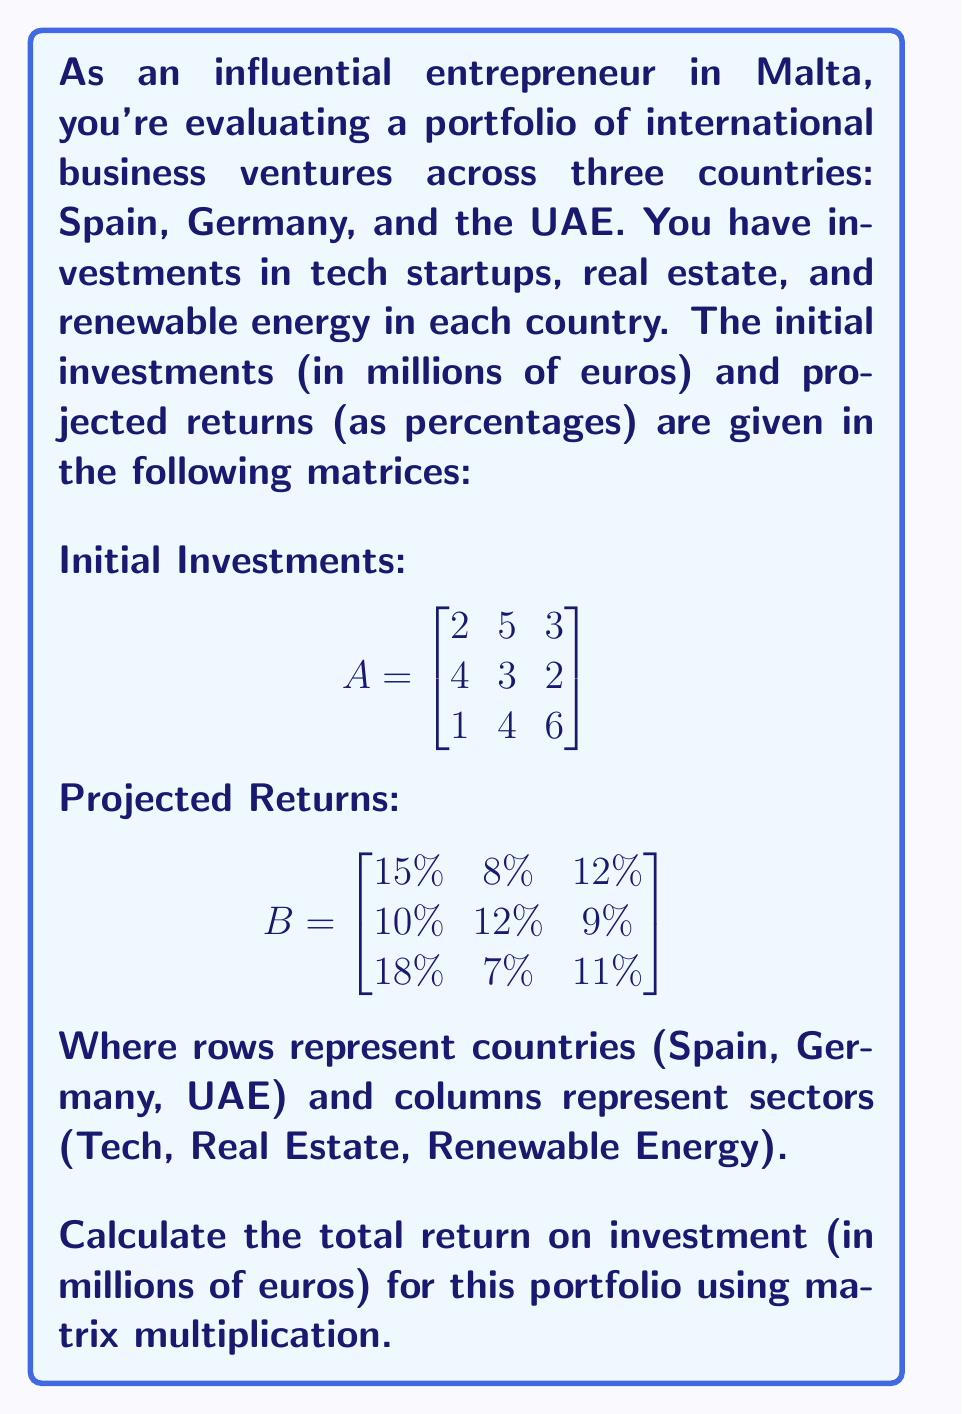Can you solve this math problem? To solve this problem, we need to follow these steps:

1) First, we need to convert the percentage returns in matrix B to decimal form:

$$B = \begin{bmatrix}
0.15 & 0.08 & 0.12 \\
0.10 & 0.12 & 0.09 \\
0.18 & 0.07 & 0.11
\end{bmatrix}$$

2) Next, we multiply matrices A and B. The resulting matrix C will give us the returns for each investment in millions of euros.

$$C = A \cdot B$$

3) To perform this multiplication:

$$c_{ij} = \sum_{k=1}^{3} a_{ik} \cdot b_{kj}$$

Let's calculate each element:

$c_{11} = 2(0.15) + 5(0.10) + 3(0.18) = 0.30 + 0.50 + 0.54 = 1.34$
$c_{12} = 2(0.08) + 5(0.12) + 3(0.07) = 0.16 + 0.60 + 0.21 = 0.97$
$c_{13} = 2(0.12) + 5(0.09) + 3(0.11) = 0.24 + 0.45 + 0.33 = 1.02$

$c_{21} = 4(0.15) + 3(0.10) + 2(0.18) = 0.60 + 0.30 + 0.36 = 1.26$
$c_{22} = 4(0.08) + 3(0.12) + 2(0.07) = 0.32 + 0.36 + 0.14 = 0.82$
$c_{23} = 4(0.12) + 3(0.09) + 2(0.11) = 0.48 + 0.27 + 0.22 = 0.97$

$c_{31} = 1(0.15) + 4(0.10) + 6(0.18) = 0.15 + 0.40 + 1.08 = 1.63$
$c_{32} = 1(0.08) + 4(0.12) + 6(0.07) = 0.08 + 0.48 + 0.42 = 0.98$
$c_{33} = 1(0.12) + 4(0.09) + 6(0.11) = 0.12 + 0.36 + 0.66 = 1.14$

4) Therefore, the resulting matrix C is:

$$C = \begin{bmatrix}
1.34 & 0.97 & 1.02 \\
1.26 & 0.82 & 0.97 \\
1.63 & 0.98 & 1.14
\end{bmatrix}$$

5) To get the total return on investment, we sum all elements of matrix C:

Total ROI = 1.34 + 0.97 + 1.02 + 1.26 + 0.82 + 0.97 + 1.63 + 0.98 + 1.14 = 10.13

Therefore, the total return on investment for this portfolio is 10.13 million euros.
Answer: €10.13 million 